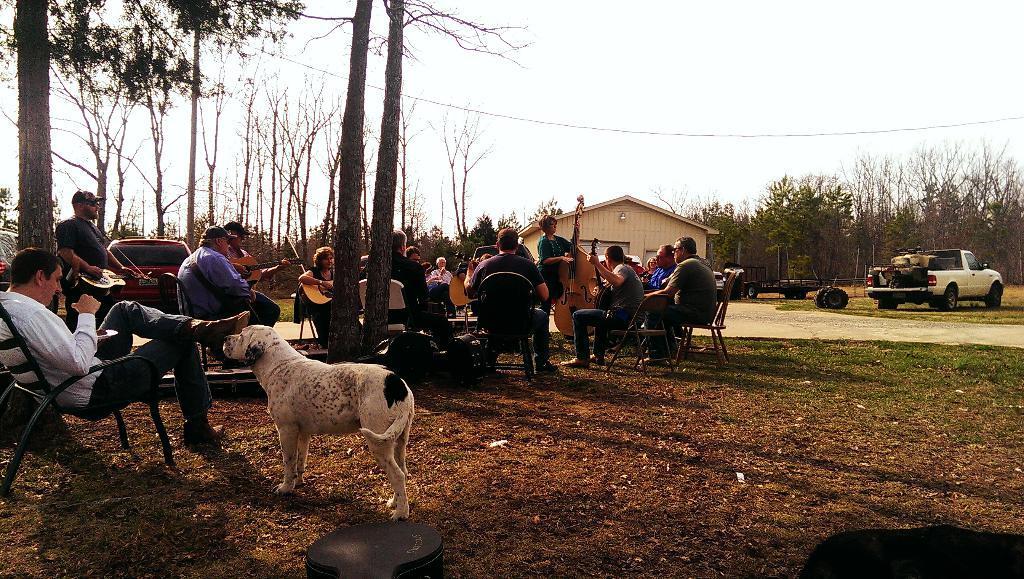Describe this image in one or two sentences. In this picture we can see some people are sitting on chairs and two people are standing and the people are playing some musical instruments and on the path there is a dog and a guitar case. Behind the people there is a house and some vehicles parked on the path. Behind the vehicles there are trees and the sky. 